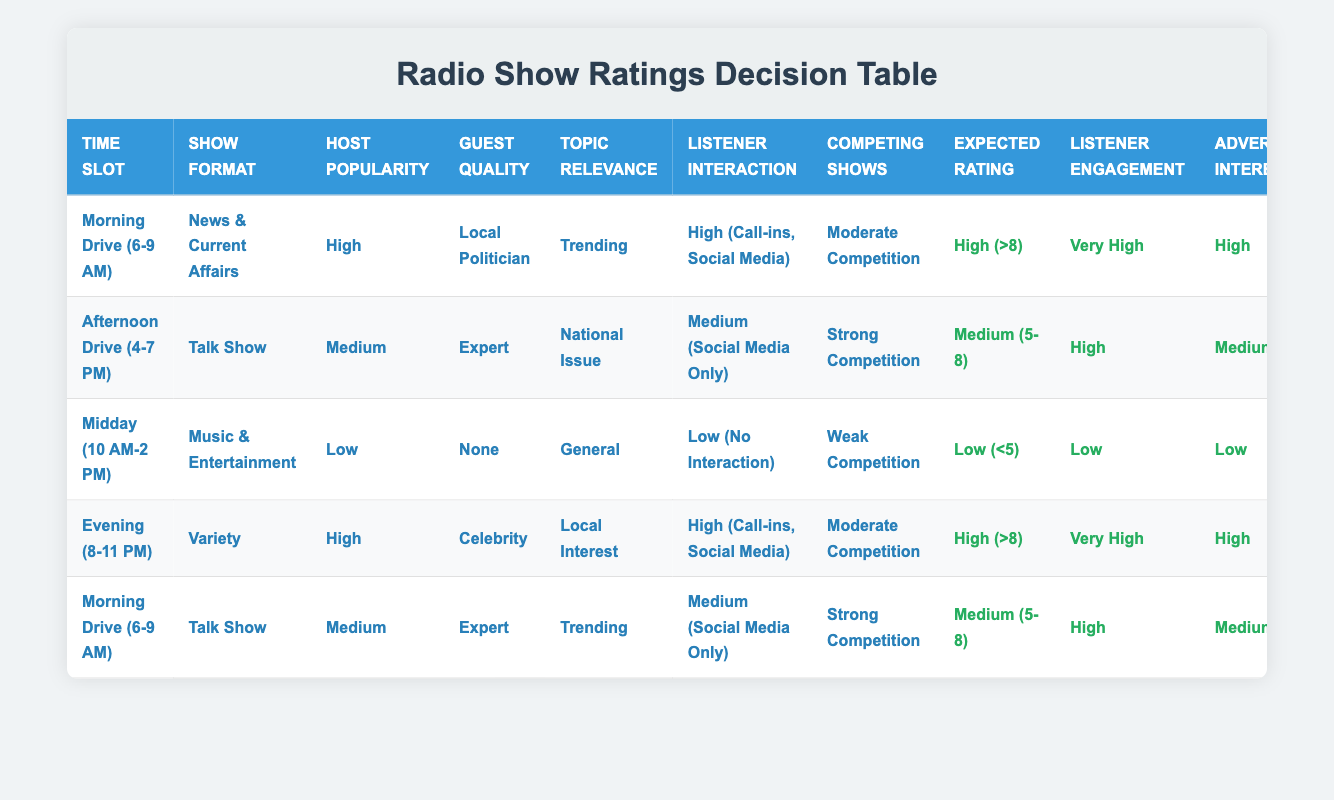What is the highest expected rating among the shows? The expected ratings range from Low (<5) to High (>8). In the table, the highest expected rating is found in the rows for "Morning Drive (6-9 AM)" with "News & Current Affairs" and "Evening (8-11 PM)" with "Variety," both resulting in a rating of High (>8).
Answer: High (>8) Which time slot has the lowest listener engagement? The listener engagement levels are listed as Very High, High, Moderate, and Low. Upon checking the rows, the "Midday (10 AM-2 PM)" show with "Music & Entertainment" has the lowest listener engagement at Low.
Answer: Low Is there a show with High host popularity and Low listener interaction? Scanning the table, the row for "Midday (10 AM-2 PM)" with "Music & Entertainment" has Low interaction but a Low host popularity. None of the rows meet the criteria of High host popularity and Low interaction. Therefore, the answer is no.
Answer: No How many shows have very high listener engagement? The listener engagement levels are Very High, High, Moderate, and Low. The rows for "Morning Drive (6-9 AM)" with "News & Current Affairs" and "Evening (8-11 PM)" with "Variety" both show Very High engagement. There are two shows with this level of engagement.
Answer: 2 What is the average expected rating for the shows with Medium host popularity? The expected ratings for shows with Medium host popularity are found in two rows: "Afternoon Drive (4-7 PM)" with a rating of Medium (5-8) and "Morning Drive (6-9 AM)" with a rating of Medium (5-8). To find the average, we consider both as the same category, which is Medium (5-8), hence the average remains Medium (5-8).
Answer: Medium (5-8) If a show has High listener interaction, what is the possible range of expected ratings it can achieve? Analyzing the table, shows with High listener interaction have ranges of expected ratings classified as High (>8) and Medium (5-8). Therefore, the possible range of expected ratings for these shows is High (>8) and Medium (5-8).
Answer: High (>8), Medium (5-8) Are there any shows scheduled in the Midday time slot with Low advertiser interest? Checking the rows, the "Midday (10 AM-2 PM)" show with "Music & Entertainment" has Low advertiser interest. Thus, there is a show in this time slot meeting the criteria.
Answer: Yes What show format is associated with very high listener engagement? From the table, both rows for "Morning Drive (6-9 AM)" with "News & Current Affairs" and "Evening (8-11 PM)" with "Variety" indicate very high listener engagement. The associated show formats are therefore News & Current Affairs and Variety.
Answer: News & Current Affairs, Variety 